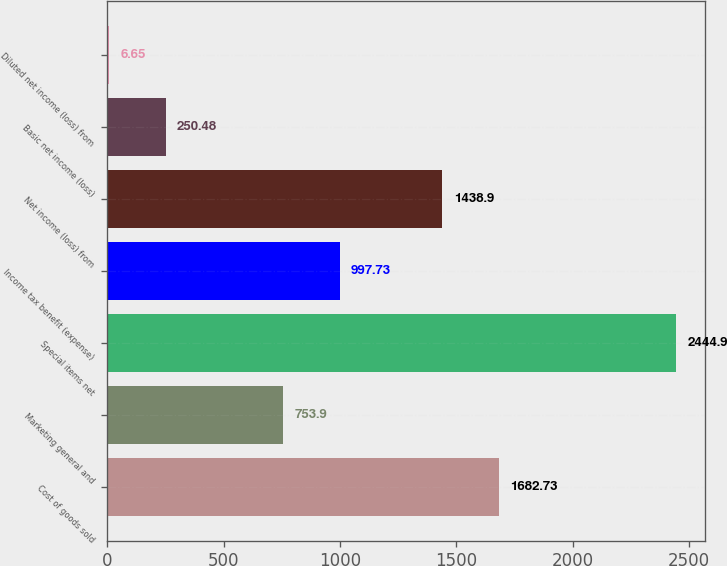Convert chart. <chart><loc_0><loc_0><loc_500><loc_500><bar_chart><fcel>Cost of goods sold<fcel>Marketing general and<fcel>Special items net<fcel>Income tax benefit (expense)<fcel>Net income (loss) from<fcel>Basic net income (loss)<fcel>Diluted net income (loss) from<nl><fcel>1682.73<fcel>753.9<fcel>2444.9<fcel>997.73<fcel>1438.9<fcel>250.48<fcel>6.65<nl></chart> 